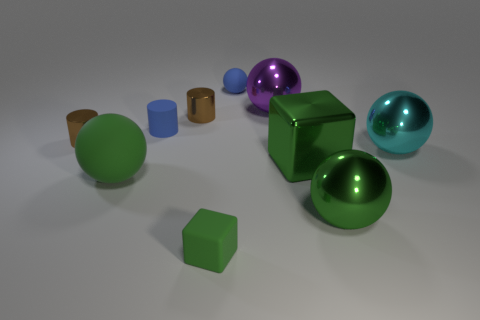Does the cyan ball have the same material as the small object in front of the big rubber object?
Keep it short and to the point. No. What number of other objects are the same shape as the purple metallic object?
Provide a succinct answer. 4. Do the large matte object and the rubber ball that is behind the rubber cylinder have the same color?
Offer a terse response. No. Is there any other thing that is the same material as the large cyan object?
Your answer should be very brief. Yes. There is a blue thing that is in front of the tiny matte thing that is right of the green matte block; what shape is it?
Offer a terse response. Cylinder. There is another block that is the same color as the tiny rubber cube; what size is it?
Offer a terse response. Large. Does the green rubber object that is left of the small green object have the same shape as the cyan thing?
Keep it short and to the point. Yes. Are there more small blue spheres in front of the big purple metallic object than small metal cylinders on the right side of the tiny green rubber object?
Your answer should be very brief. No. How many purple shiny things are in front of the cube that is left of the large purple shiny sphere?
Offer a terse response. 0. There is another cube that is the same color as the small block; what is it made of?
Offer a terse response. Metal. 